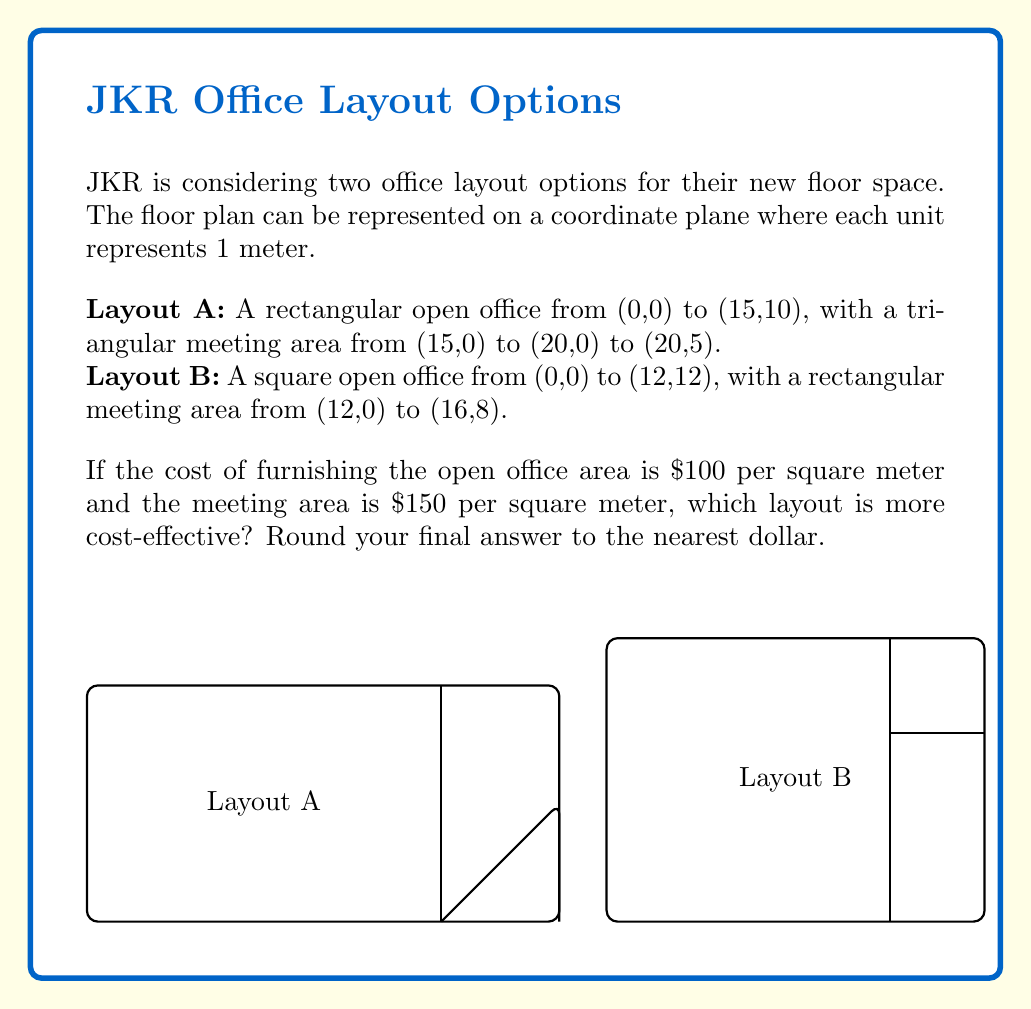Could you help me with this problem? Let's approach this step-by-step:

1) Calculate the areas for Layout A:
   Open office area: $15 \times 10 = 150$ sq meters
   Meeting area (triangle): $\frac{1}{2} \times 5 \times 5 = 12.5$ sq meters

2) Calculate the areas for Layout B:
   Open office area: $12 \times 12 = 144$ sq meters
   Meeting area (rectangle): $4 \times 8 = 32$ sq meters

3) Calculate the cost for Layout A:
   Open office: $150 \times \$100 = \$15,000$
   Meeting area: $12.5 \times \$150 = \$1,875$
   Total: $\$15,000 + \$1,875 = \$16,875$

4) Calculate the cost for Layout B:
   Open office: $144 \times \$100 = \$14,400$
   Meeting area: $32 \times \$150 = \$4,800$
   Total: $\$14,400 + \$4,800 = \$19,200$

5) Compare the costs:
   Layout A: $\$16,875$
   Layout B: $\$19,200$

Layout A is more cost-effective, saving $\$19,200 - \$16,875 = \$2,325$.
Answer: Layout A, saving $2,325 